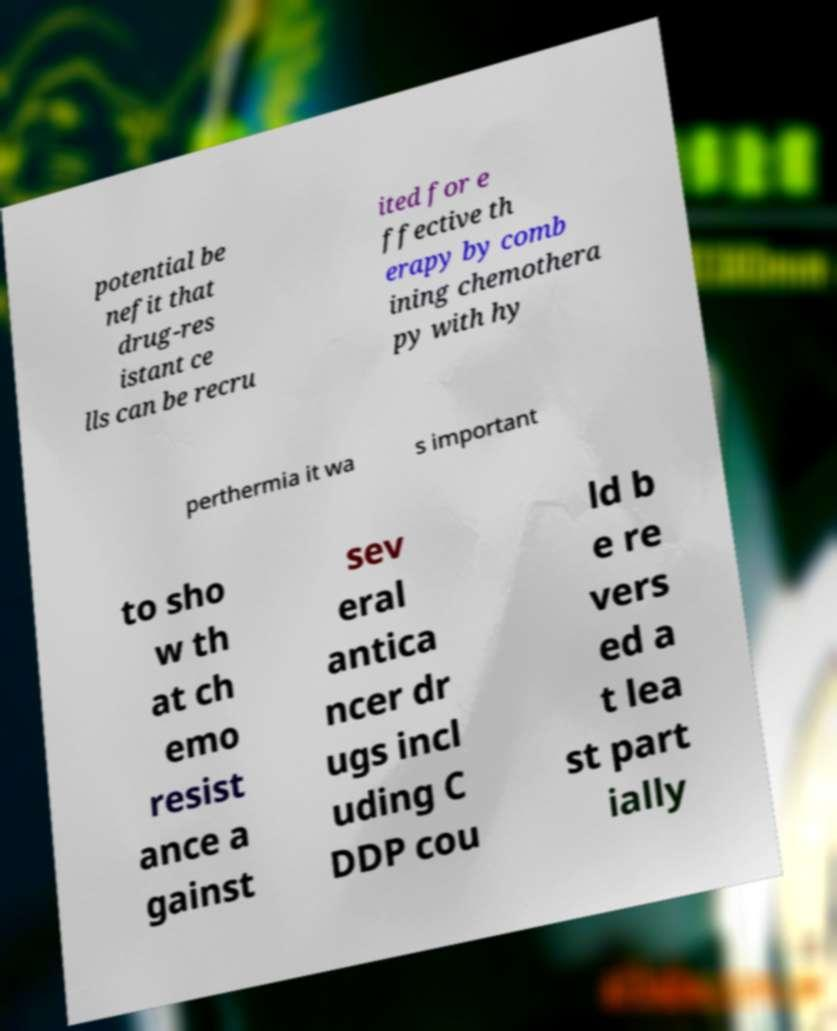Please read and relay the text visible in this image. What does it say? potential be nefit that drug-res istant ce lls can be recru ited for e ffective th erapy by comb ining chemothera py with hy perthermia it wa s important to sho w th at ch emo resist ance a gainst sev eral antica ncer dr ugs incl uding C DDP cou ld b e re vers ed a t lea st part ially 